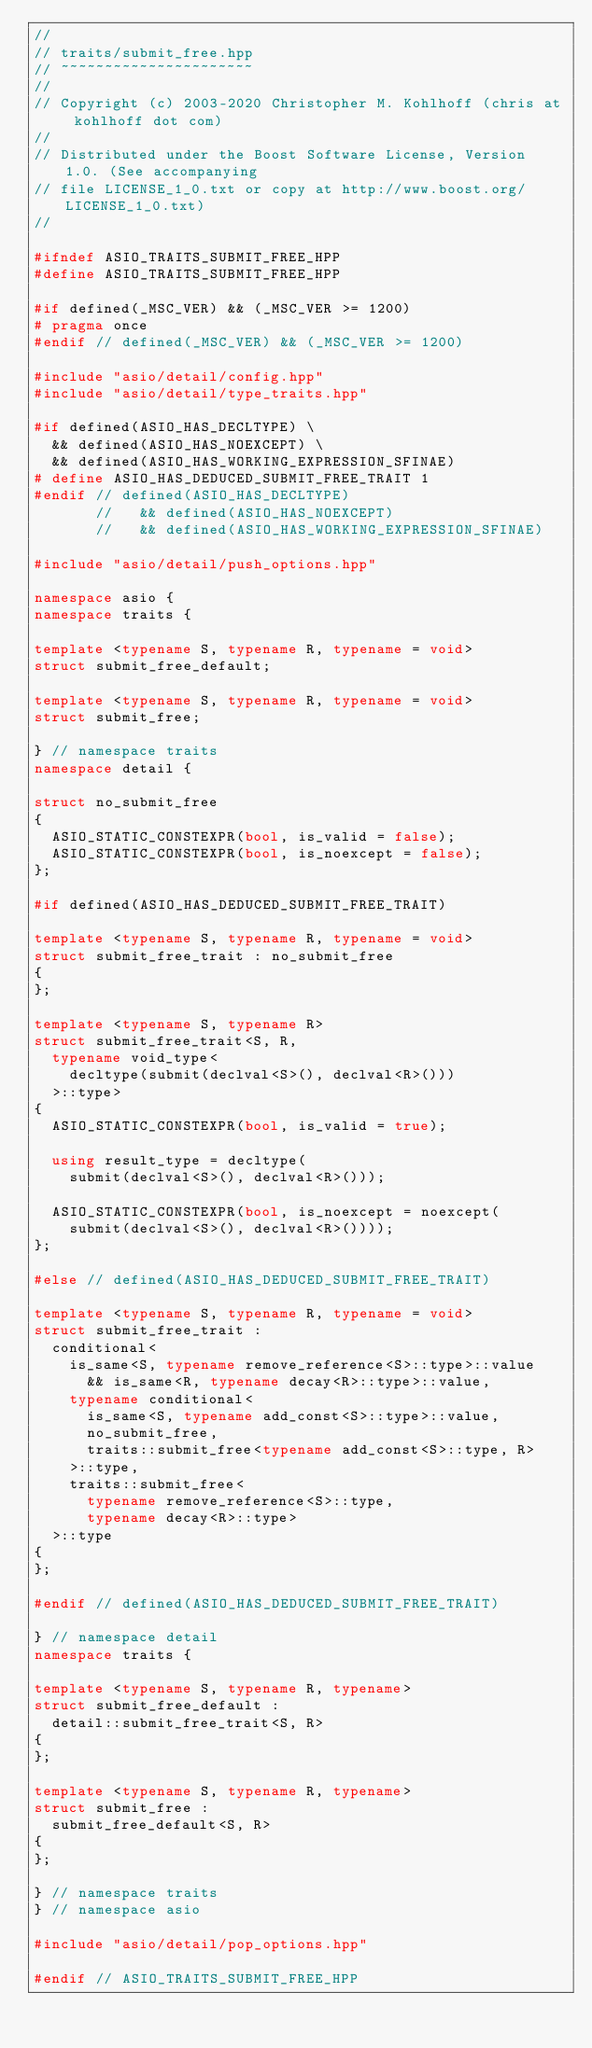<code> <loc_0><loc_0><loc_500><loc_500><_C++_>//
// traits/submit_free.hpp
// ~~~~~~~~~~~~~~~~~~~~~~
//
// Copyright (c) 2003-2020 Christopher M. Kohlhoff (chris at kohlhoff dot com)
//
// Distributed under the Boost Software License, Version 1.0. (See accompanying
// file LICENSE_1_0.txt or copy at http://www.boost.org/LICENSE_1_0.txt)
//

#ifndef ASIO_TRAITS_SUBMIT_FREE_HPP
#define ASIO_TRAITS_SUBMIT_FREE_HPP

#if defined(_MSC_VER) && (_MSC_VER >= 1200)
# pragma once
#endif // defined(_MSC_VER) && (_MSC_VER >= 1200)

#include "asio/detail/config.hpp"
#include "asio/detail/type_traits.hpp"

#if defined(ASIO_HAS_DECLTYPE) \
  && defined(ASIO_HAS_NOEXCEPT) \
  && defined(ASIO_HAS_WORKING_EXPRESSION_SFINAE)
# define ASIO_HAS_DEDUCED_SUBMIT_FREE_TRAIT 1
#endif // defined(ASIO_HAS_DECLTYPE)
       //   && defined(ASIO_HAS_NOEXCEPT)
       //   && defined(ASIO_HAS_WORKING_EXPRESSION_SFINAE)

#include "asio/detail/push_options.hpp"

namespace asio {
namespace traits {

template <typename S, typename R, typename = void>
struct submit_free_default;

template <typename S, typename R, typename = void>
struct submit_free;

} // namespace traits
namespace detail {

struct no_submit_free
{
  ASIO_STATIC_CONSTEXPR(bool, is_valid = false);
  ASIO_STATIC_CONSTEXPR(bool, is_noexcept = false);
};

#if defined(ASIO_HAS_DEDUCED_SUBMIT_FREE_TRAIT)

template <typename S, typename R, typename = void>
struct submit_free_trait : no_submit_free
{
};

template <typename S, typename R>
struct submit_free_trait<S, R,
  typename void_type<
    decltype(submit(declval<S>(), declval<R>()))
  >::type>
{
  ASIO_STATIC_CONSTEXPR(bool, is_valid = true);

  using result_type = decltype(
    submit(declval<S>(), declval<R>()));

  ASIO_STATIC_CONSTEXPR(bool, is_noexcept = noexcept(
    submit(declval<S>(), declval<R>())));
};

#else // defined(ASIO_HAS_DEDUCED_SUBMIT_FREE_TRAIT)

template <typename S, typename R, typename = void>
struct submit_free_trait :
  conditional<
    is_same<S, typename remove_reference<S>::type>::value
      && is_same<R, typename decay<R>::type>::value,
    typename conditional<
      is_same<S, typename add_const<S>::type>::value,
      no_submit_free,
      traits::submit_free<typename add_const<S>::type, R>
    >::type,
    traits::submit_free<
      typename remove_reference<S>::type,
      typename decay<R>::type>
  >::type
{
};

#endif // defined(ASIO_HAS_DEDUCED_SUBMIT_FREE_TRAIT)

} // namespace detail
namespace traits {

template <typename S, typename R, typename>
struct submit_free_default :
  detail::submit_free_trait<S, R>
{
};

template <typename S, typename R, typename>
struct submit_free :
  submit_free_default<S, R>
{
};

} // namespace traits
} // namespace asio

#include "asio/detail/pop_options.hpp"

#endif // ASIO_TRAITS_SUBMIT_FREE_HPP
</code> 